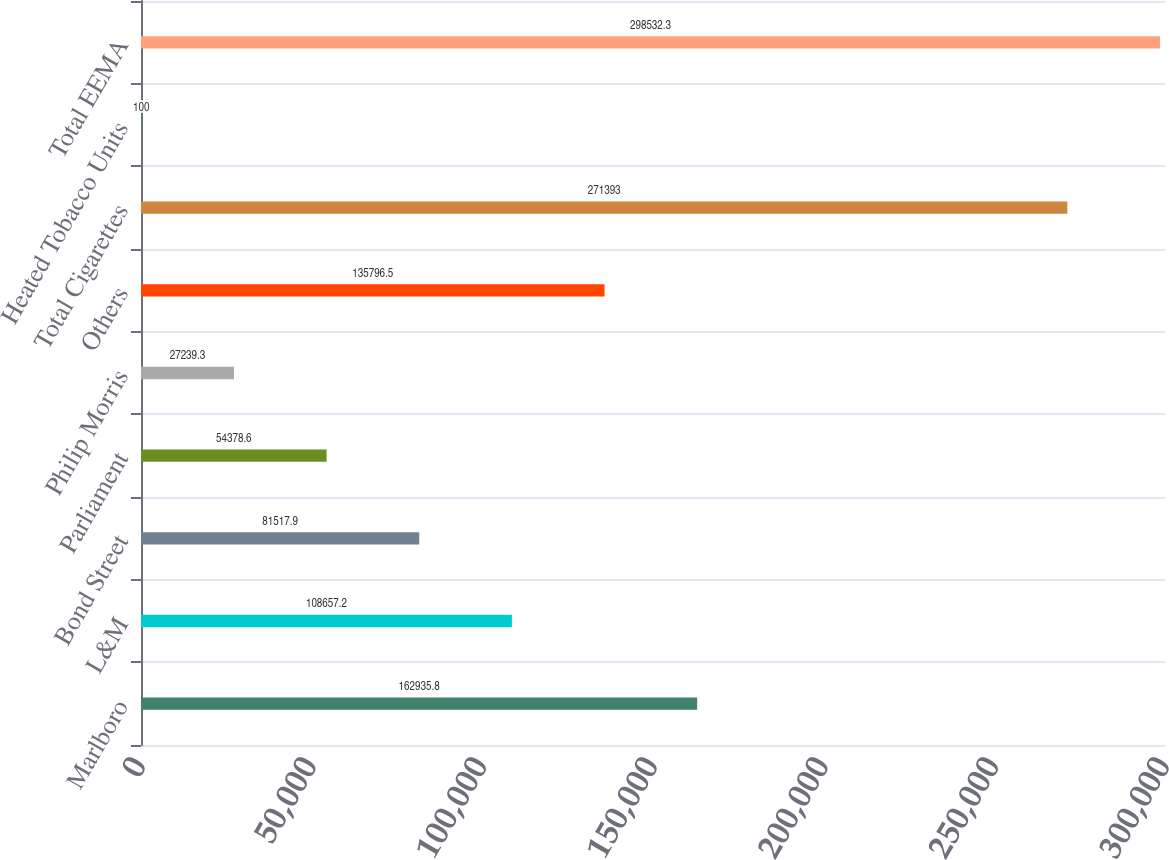<chart> <loc_0><loc_0><loc_500><loc_500><bar_chart><fcel>Marlboro<fcel>L&M<fcel>Bond Street<fcel>Parliament<fcel>Philip Morris<fcel>Others<fcel>Total Cigarettes<fcel>Heated Tobacco Units<fcel>Total EEMA<nl><fcel>162936<fcel>108657<fcel>81517.9<fcel>54378.6<fcel>27239.3<fcel>135796<fcel>271393<fcel>100<fcel>298532<nl></chart> 